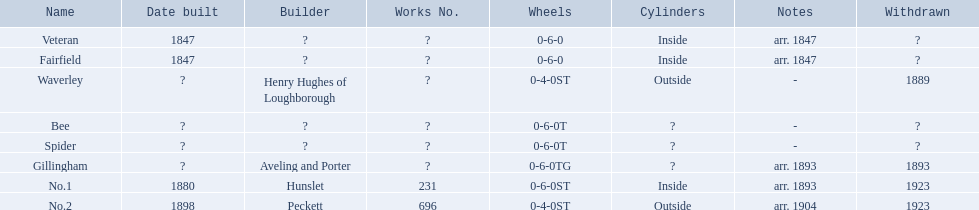Which have known built dates? Veteran, Fairfield, No.1, No.2. What other was built in 1847? Veteran. What are the different names for the alderney railway? Veteran, Fairfield, Waverley, Bee, Spider, Gillingham, No.1, No.2. In which year was the farfield established? 1847. Were there any other constructions in that year? Veteran. 